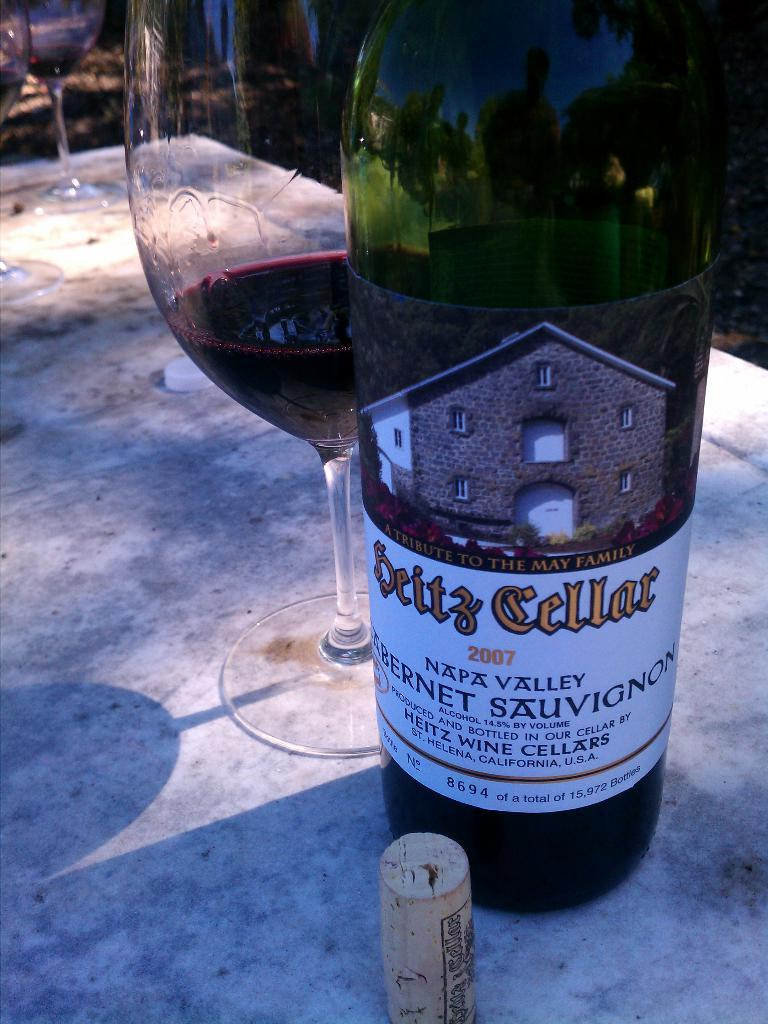How many glasses are on the table in the image? There are three glasses on the table in the image. What else can be seen on the table besides the glasses? There is a bottle on the table. Can you describe the bottle in the image? The bottle has a label on it. What type of insurance is advertised on the label of the bottle in the image? There is no insurance mentioned on the label of the bottle in the image. How does the zephyr affect the arrangement of the glasses on the table? There is no mention of a zephyr in the image, and therefore it cannot affect the arrangement of the glasses. 